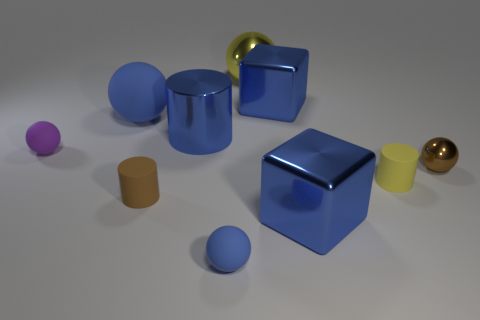There is a matte cylinder that is the same color as the small metallic ball; what is its size?
Your answer should be compact. Small. How many things are tiny purple metallic blocks or tiny rubber spheres?
Ensure brevity in your answer.  2. There is another shiny object that is the same size as the purple thing; what is its color?
Provide a succinct answer. Brown. Is the shape of the purple object the same as the big metallic thing that is in front of the tiny brown rubber thing?
Provide a short and direct response. No. How many things are either tiny brown objects that are behind the tiny brown cylinder or blue shiny objects that are in front of the tiny brown shiny ball?
Your response must be concise. 2. The large rubber object that is the same color as the metallic cylinder is what shape?
Give a very brief answer. Sphere. What shape is the blue metal object that is left of the large yellow thing?
Offer a very short reply. Cylinder. There is a blue matte thing in front of the purple sphere; is it the same shape as the yellow matte thing?
Offer a terse response. No. How many things are either small matte balls to the left of the tiny blue object or yellow rubber blocks?
Provide a short and direct response. 1. There is a metallic object that is the same shape as the tiny brown matte thing; what is its color?
Offer a terse response. Blue. 